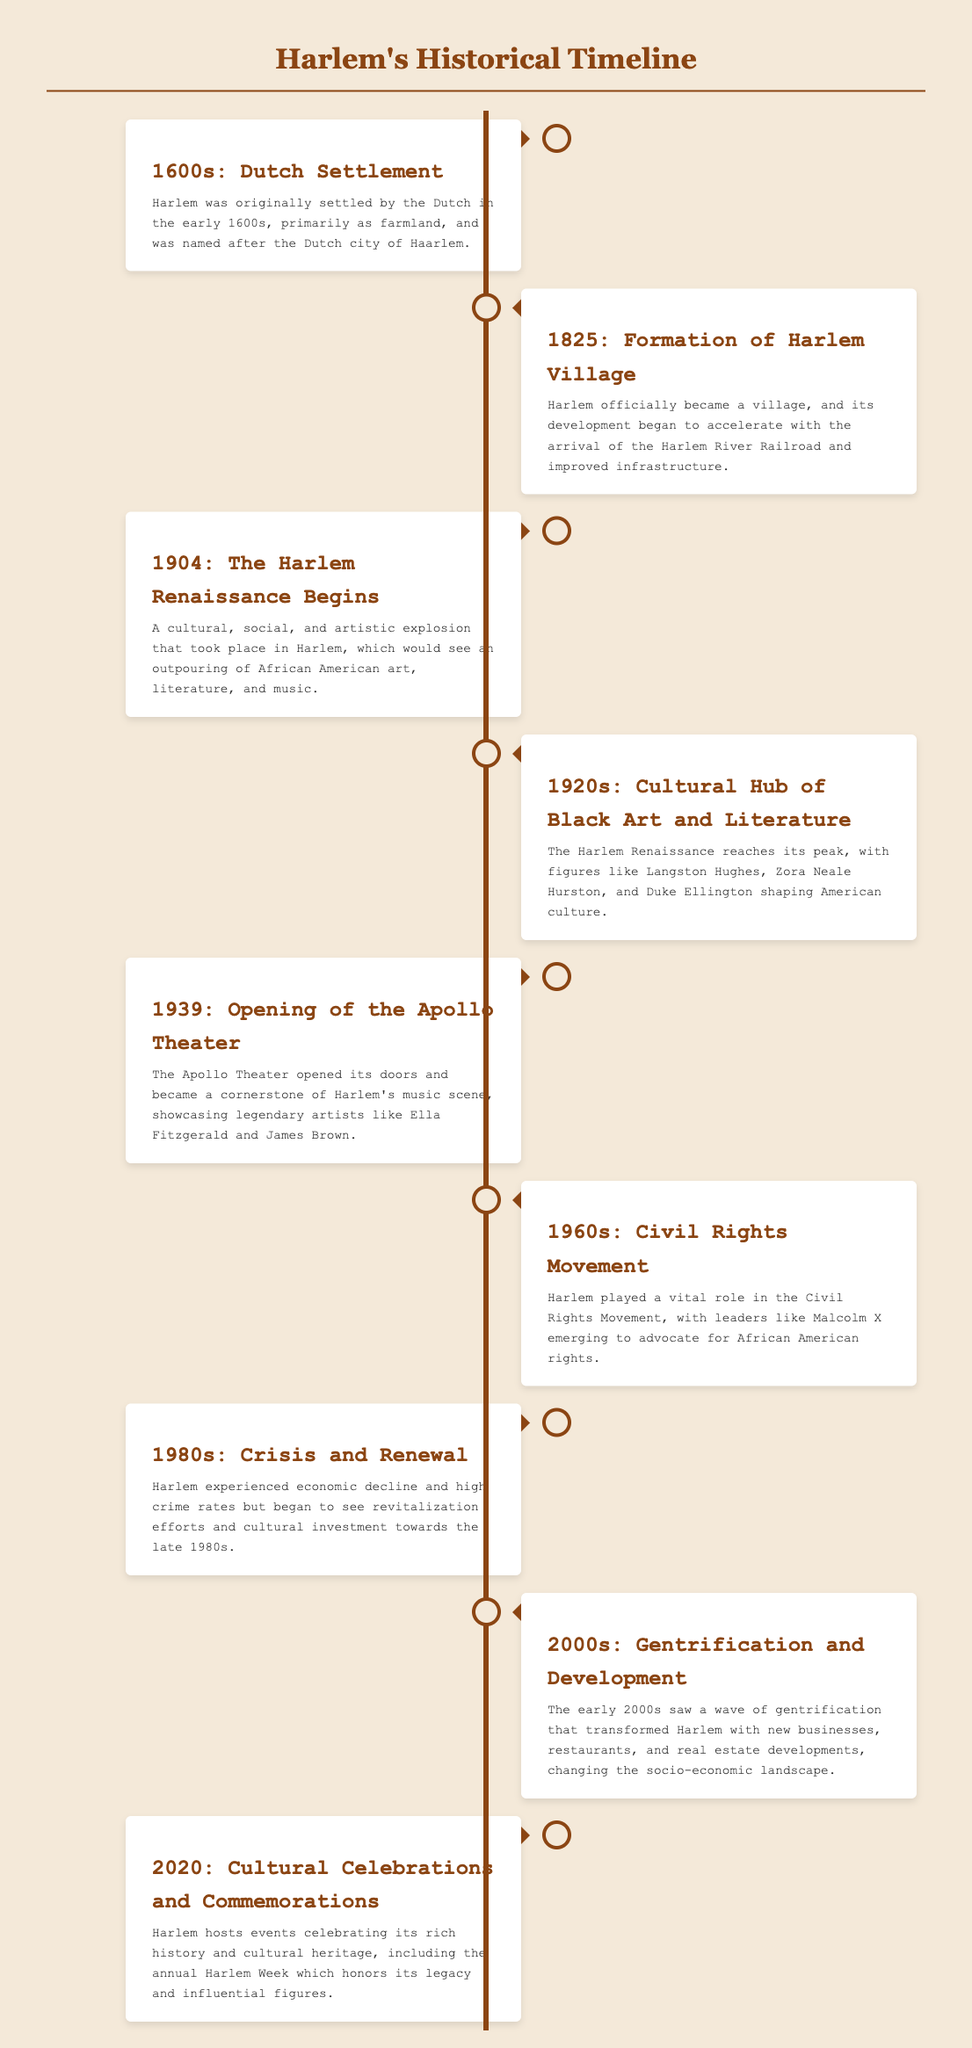What year was Harlem originally settled? The document states that Harlem was originally settled by the Dutch in the early 1600s.
Answer: 1600s What event marked the formation of Harlem Village? The timeline indicates that Harlem officially became a village in 1825, which accelerated its development.
Answer: Formation of Harlem Village Who were some key figures of the Harlem Renaissance? The timeline mentions figures like Langston Hughes and Zora Neale Hurston during the Harlem Renaissance in the 1920s.
Answer: Langston Hughes, Zora Neale Hurston What significant venue opened in 1939? The document notes the opening of the Apollo Theater in 1939, a landmark in Harlem's music scene.
Answer: Apollo Theater In which decade did Harlem play a vital role in the Civil Rights Movement? The document specifies that the 1960s was the decade when Harlem was active in the Civil Rights Movement.
Answer: 1960s What cultural event is held annually in Harlem? The document highlights the annual Harlem Week as a celebration of its rich history and cultural heritage.
Answer: Harlem Week What trend began in the early 2000s in Harlem? The document indicates that a wave of gentrification transformed Harlem in the early 2000s.
Answer: Gentrification How did Harlem's socio-economic landscape change in the 1980s? According to the document, Harlem experienced economic decline but began to see revitalization efforts by the late 1980s.
Answer: Crisis and Renewal 